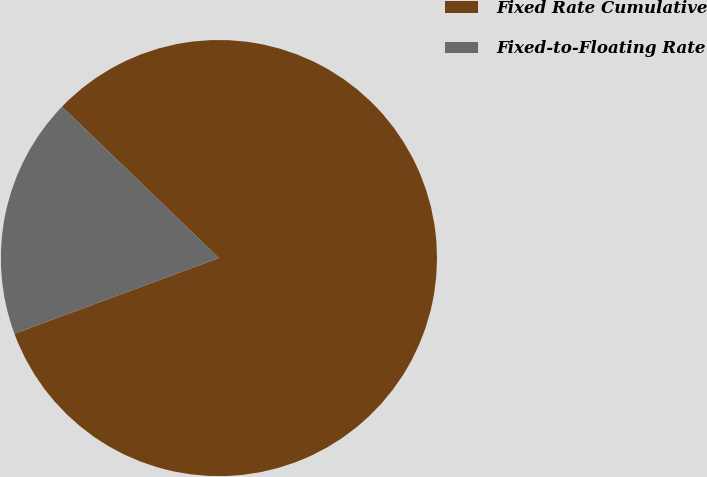Convert chart. <chart><loc_0><loc_0><loc_500><loc_500><pie_chart><fcel>Fixed Rate Cumulative<fcel>Fixed-to-Floating Rate<nl><fcel>82.14%<fcel>17.86%<nl></chart> 